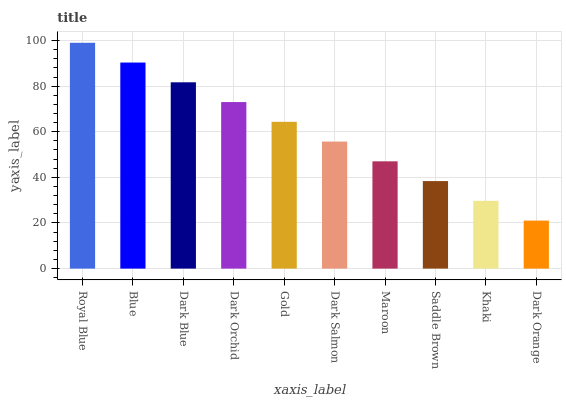Is Dark Orange the minimum?
Answer yes or no. Yes. Is Royal Blue the maximum?
Answer yes or no. Yes. Is Blue the minimum?
Answer yes or no. No. Is Blue the maximum?
Answer yes or no. No. Is Royal Blue greater than Blue?
Answer yes or no. Yes. Is Blue less than Royal Blue?
Answer yes or no. Yes. Is Blue greater than Royal Blue?
Answer yes or no. No. Is Royal Blue less than Blue?
Answer yes or no. No. Is Gold the high median?
Answer yes or no. Yes. Is Dark Salmon the low median?
Answer yes or no. Yes. Is Dark Orchid the high median?
Answer yes or no. No. Is Maroon the low median?
Answer yes or no. No. 